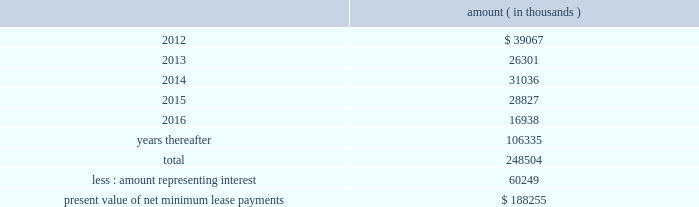Entergy corporation and subsidiaries notes to financial statements sale and leaseback transactions waterford 3 lease obligations in 1989 , in three separate but substantially identical transactions , entergy louisiana sold and leased back undivided interests in waterford 3 for the aggregate sum of $ 353.6 million .
The interests represent approximately 9.3% ( 9.3 % ) of waterford 3 .
The leases expire in 2017 .
Under certain circumstances , entergy louisiana may repurchase the leased interests prior to the end of the term of the leases .
At the end of the lease terms , entergy louisiana has the option to repurchase the leased interests in waterford 3 at fair market value or to renew the leases for either fair market value or , under certain conditions , a fixed rate .
Entergy louisiana issued $ 208.2 million of non-interest bearing first mortgage bonds as collateral for the equity portion of certain amounts payable under the leases .
Upon the occurrence of certain events , entergy louisiana may be obligated to assume the outstanding bonds used to finance the purchase of the interests in the unit and to pay an amount sufficient to withdraw from the lease transaction .
Such events include lease events of default , events of loss , deemed loss events , or certain adverse 201cfinancial events . 201d 201cfinancial events 201d include , among other things , failure by entergy louisiana , following the expiration of any applicable grace or cure period , to maintain ( i ) total equity capital ( including preferred membership interests ) at least equal to 30% ( 30 % ) of adjusted capitalization , or ( ii ) a fixed charge coverage ratio of at least 1.50 computed on a rolling 12 month basis .
As of december 31 , 2011 , entergy louisiana was in compliance with these provisions .
As of december 31 , 2011 , entergy louisiana had future minimum lease payments ( reflecting an overall implicit rate of 7.45% ( 7.45 % ) ) in connection with the waterford 3 sale and leaseback transactions , which are recorded as long-term debt , as follows : amount ( in thousands ) .
Grand gulf lease obligations in 1988 , in two separate but substantially identical transactions , system energy sold and leased back undivided ownership interests in grand gulf for the aggregate sum of $ 500 million .
The interests represent approximately 11.5% ( 11.5 % ) of grand gulf .
The leases expire in 2015 .
Under certain circumstances , system entergy may repurchase the leased interests prior to the end of the term of the leases .
At the end of the lease terms , system energy has the option to repurchase the leased interests in grand gulf at fair market value or to renew the leases for either fair market value or , under certain conditions , a fixed rate .
System energy is required to report the sale-leaseback as a financing transaction in its financial statements .
For financial reporting purposes , system energy expenses the interest portion of the lease obligation and the plant depreciation .
However , operating revenues include the recovery of the lease payments because the transactions are accounted for as a sale and leaseback for ratemaking purposes .
Consistent with a recommendation contained in a .
As of december 31 , 2011 , what was the percent of the entergy louisiana future minimum lease payments that was due in 2014? 
Computations: (31036 / 248504)
Answer: 0.12489. 